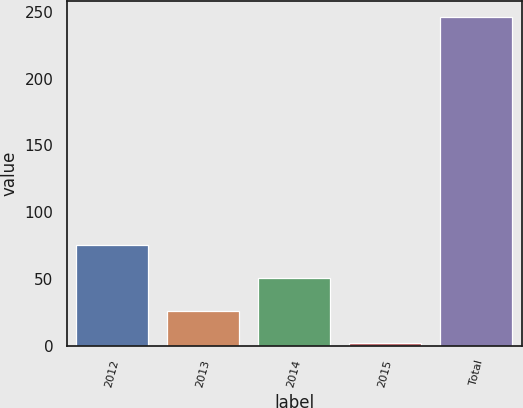Convert chart. <chart><loc_0><loc_0><loc_500><loc_500><bar_chart><fcel>2012<fcel>2013<fcel>2014<fcel>2015<fcel>Total<nl><fcel>75.2<fcel>26.4<fcel>50.8<fcel>2<fcel>246<nl></chart> 